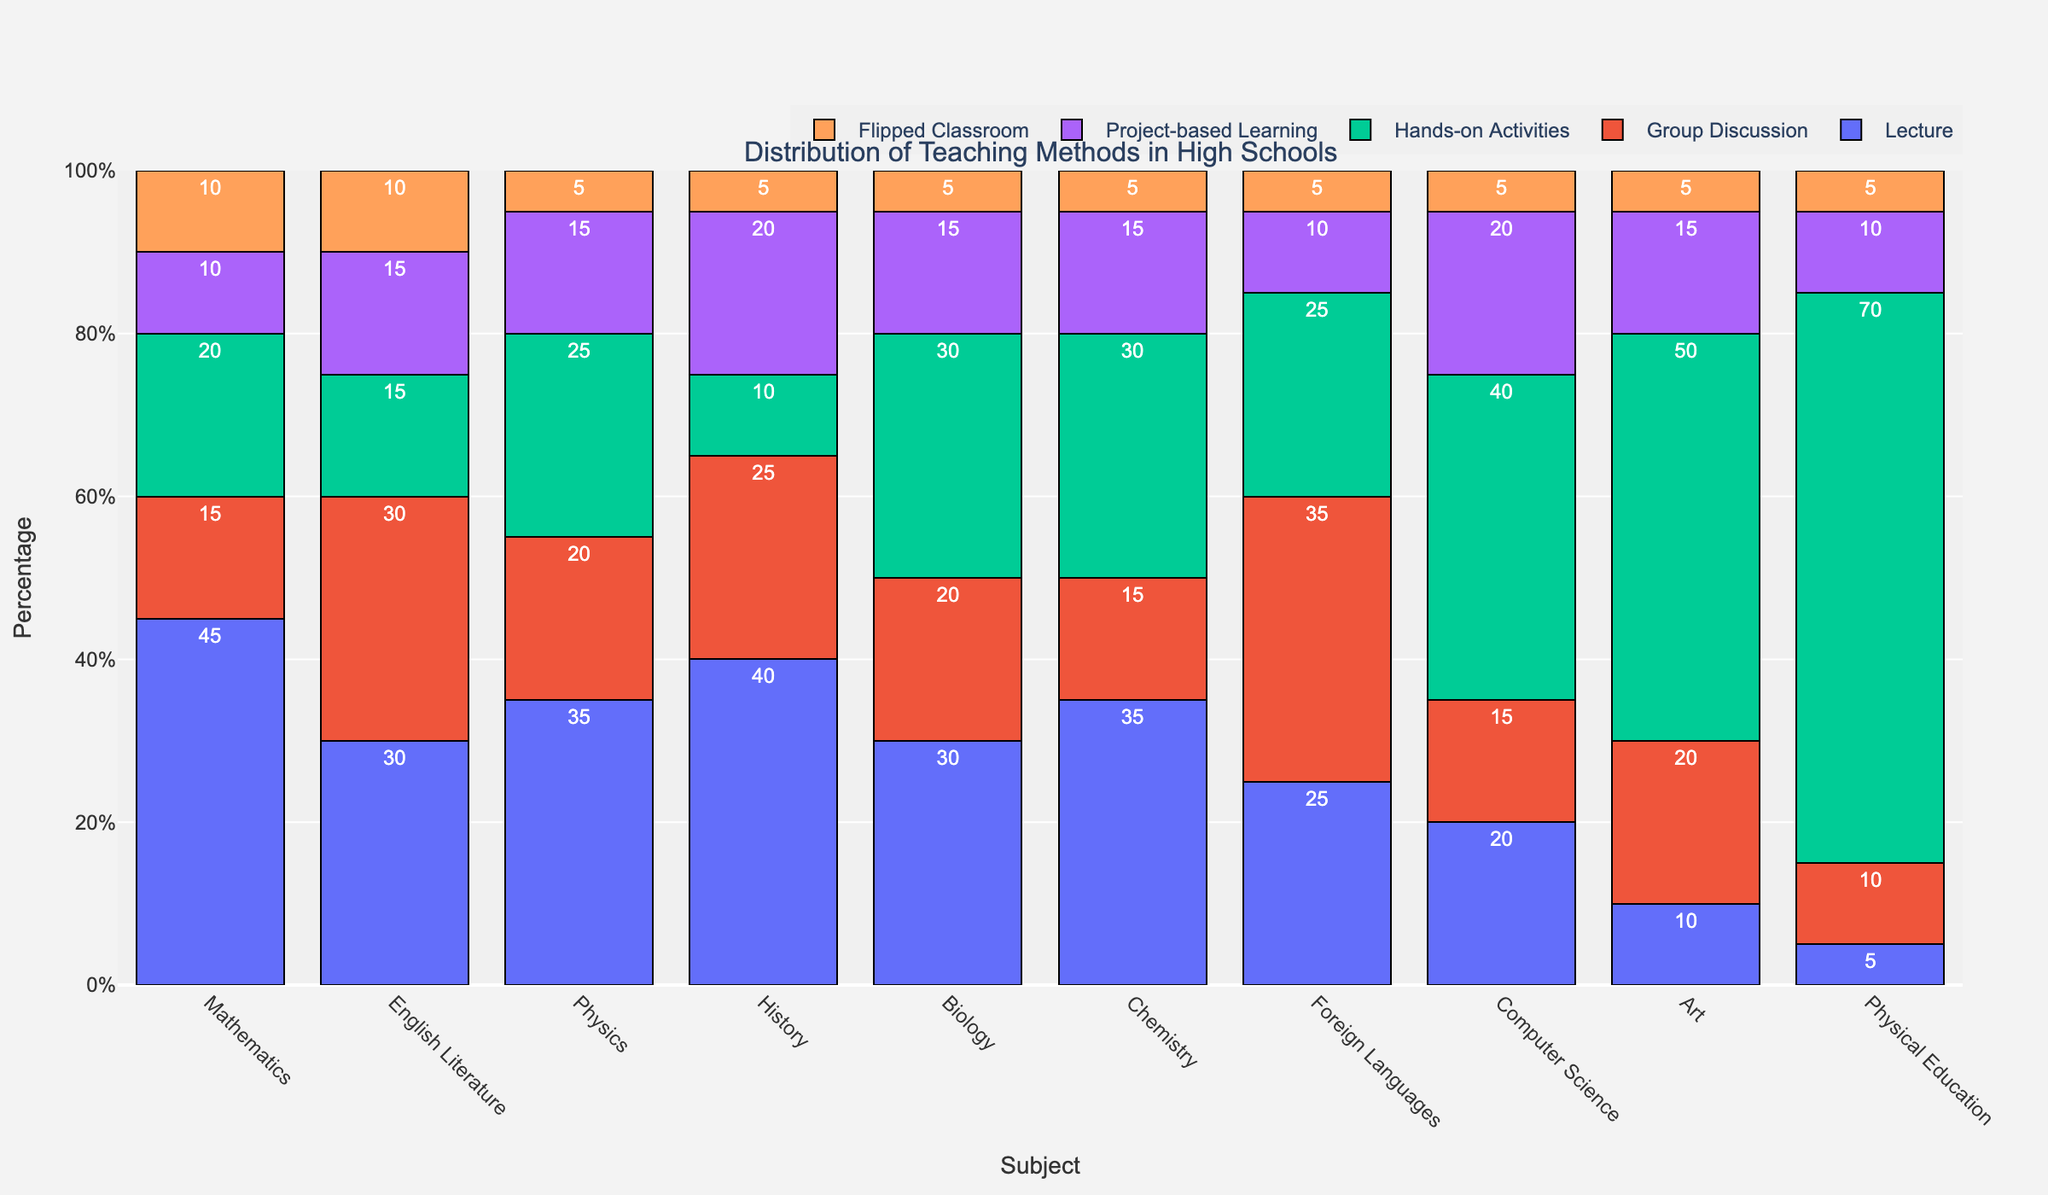Which subject uses Lecture methods the most? To determine which subject uses Lecture methods the most, look at the height of the bars labeled "Lecture" for each subject. The tallest bar represents the subject that uses Lecture methods the most.
Answer: Mathematics Which teaching method is least used in Art? To find the least used teaching method in Art, we need to look at the bars corresponding to each method within the Art category and identify the shortest bar.
Answer: Lecture What is the total percentage of Project-based Learning across all subjects? Summing the percentages of Project-based Learning from each subject gives: 10 (Mathematics) + 15 (English Literature) + 15 (Physics) + 20 (History) + 15 (Biology) + 15 (Chemistry) + 10 (Foreign Languages) + 20 (Computer Science) + 15 (Art) + 10 (Physical Education) = 135%.
Answer: 135% How do Hands-on Activities in Biology compare to those in Chemistry? To compare Hands-on Activities in Biology and Chemistry, look at the height of the bars for Hands-on Activities in both subjects. Both bars have the same height.
Answer: Equal What is the combined percentage of Lecture and Group Discussion methods in History? Adding the percentages of Lecture and Group Discussion methods in History gives: 40 (Lecture) + 25 (Group Discussion) = 65%.
Answer: 65% Which subject relies most heavily on Flipped Classroom methods? Determine which subject has the highest bar for the Flipped Classroom category.
Answer: Mathematics, English Literature, History, Biology, Chemistry, Foreign Languages, Computer Science, Art, Physical Education (All have 5%) Is Group Discussion more prevalent in Foreign Languages or Biology? Compare the height of the bars for Group Discussion in Foreign Languages and Biology. Foreign Languages shows a higher bar.
Answer: Foreign Languages What is the average usage percentage of Hands-on Activities across Mathematics, Physics, and Chemistry? To find the average, sum the percentages of Hands-on Activities for Mathematics, Physics, and Chemistry and then divide by 3: (20 + 25 + 30) / 3 = 75 / 3 = 25%.
Answer: 25% In which subject is Project-based Learning most similarly valued to Flipped Classroom? Find the subject where the bars for Project-based Learning and Flipped Classroom are closest in height. Both methods are equal in Mathematics with values 10% each, and English Literature has 15% (Project-based Learning) and 10% (Flipped Classroom) with a difference of 5%. Therefore, Mathematics is the closest.
Answer: Mathematics 